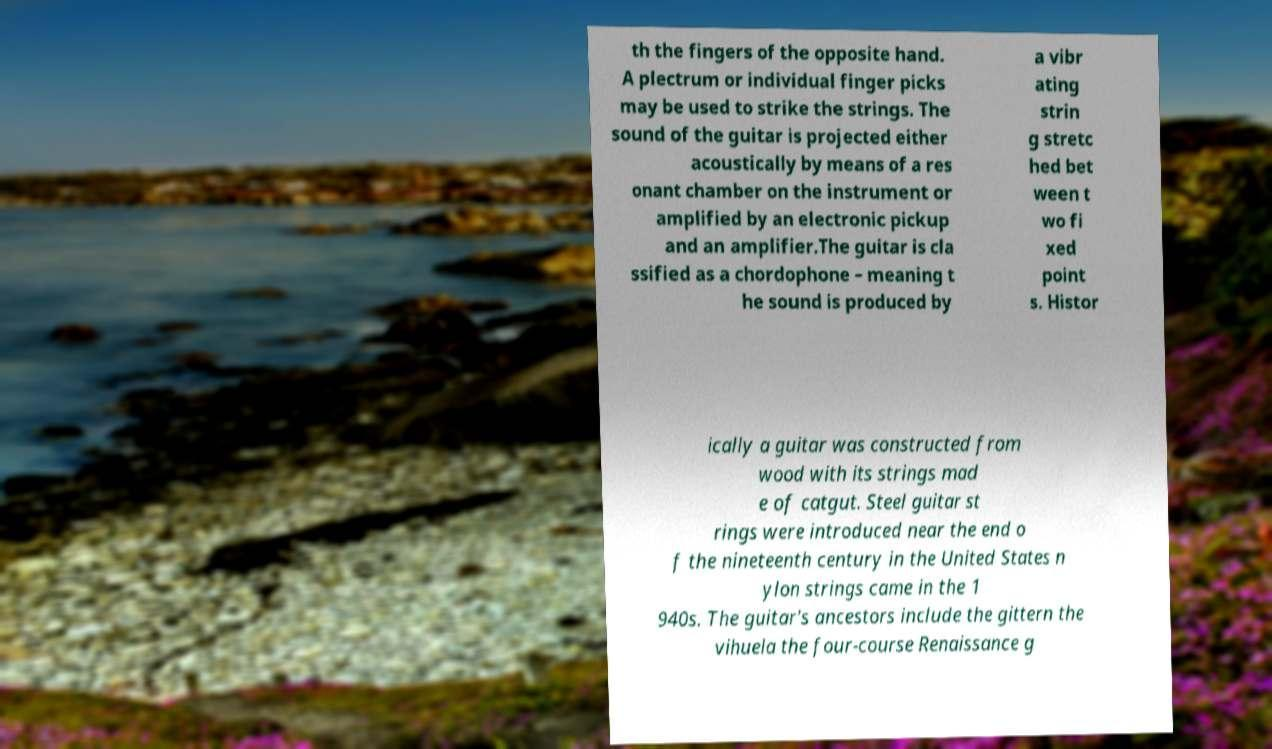Can you read and provide the text displayed in the image?This photo seems to have some interesting text. Can you extract and type it out for me? th the fingers of the opposite hand. A plectrum or individual finger picks may be used to strike the strings. The sound of the guitar is projected either acoustically by means of a res onant chamber on the instrument or amplified by an electronic pickup and an amplifier.The guitar is cla ssified as a chordophone – meaning t he sound is produced by a vibr ating strin g stretc hed bet ween t wo fi xed point s. Histor ically a guitar was constructed from wood with its strings mad e of catgut. Steel guitar st rings were introduced near the end o f the nineteenth century in the United States n ylon strings came in the 1 940s. The guitar's ancestors include the gittern the vihuela the four-course Renaissance g 